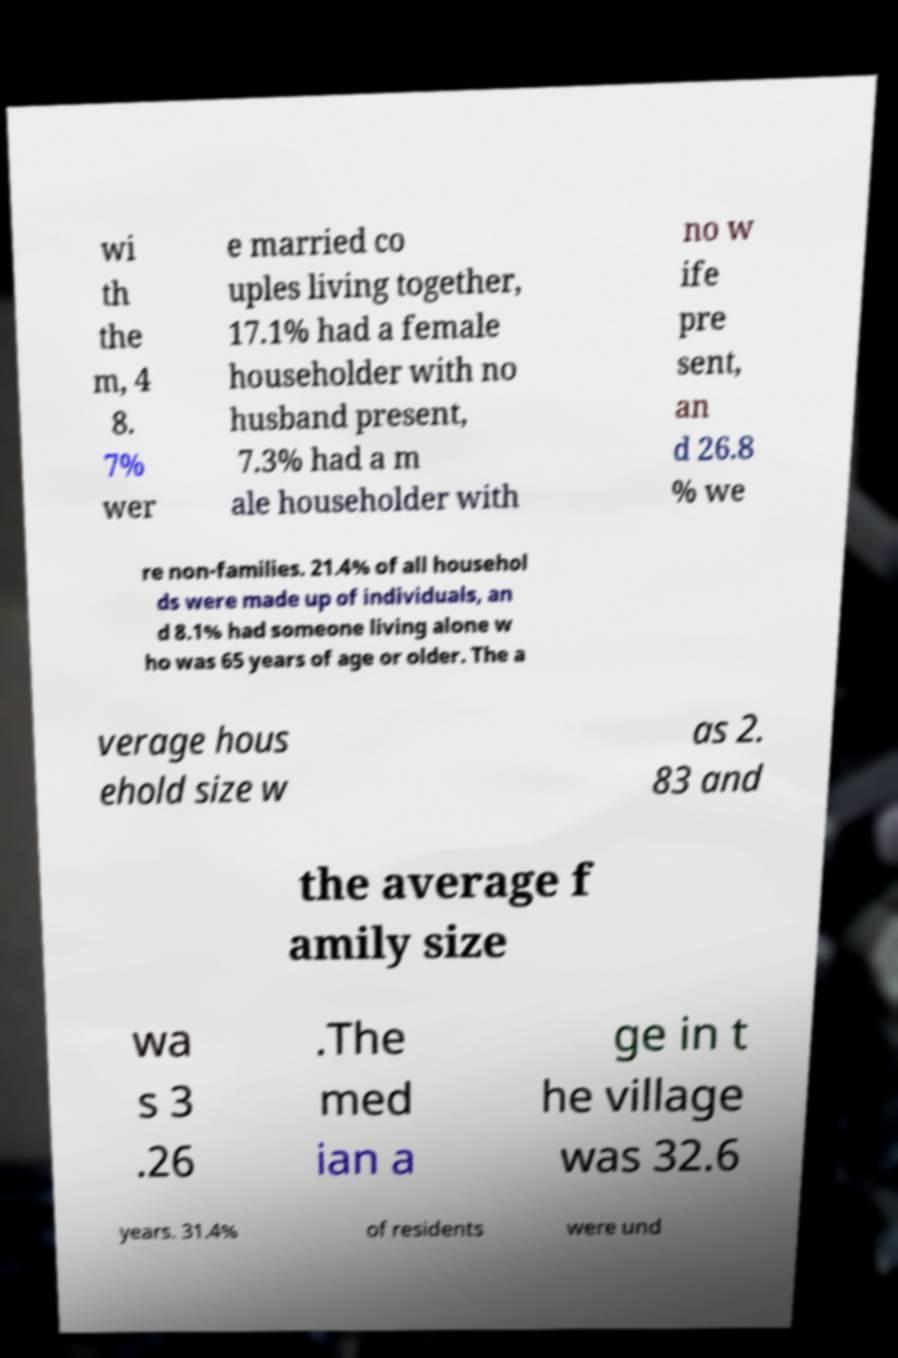There's text embedded in this image that I need extracted. Can you transcribe it verbatim? wi th the m, 4 8. 7% wer e married co uples living together, 17.1% had a female householder with no husband present, 7.3% had a m ale householder with no w ife pre sent, an d 26.8 % we re non-families. 21.4% of all househol ds were made up of individuals, an d 8.1% had someone living alone w ho was 65 years of age or older. The a verage hous ehold size w as 2. 83 and the average f amily size wa s 3 .26 .The med ian a ge in t he village was 32.6 years. 31.4% of residents were und 